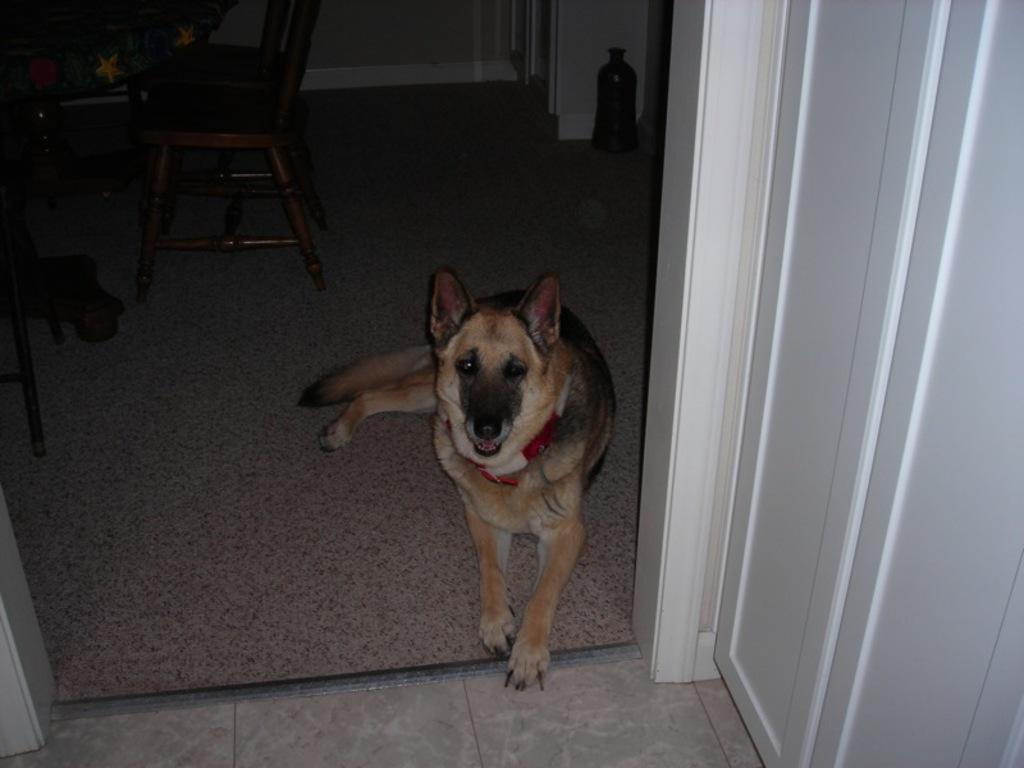What type of animal is in the picture? There is a dog in the picture. What type of furniture can be seen in the picture? There are chairs and a table in the picture. What object is visible that might contain a liquid? There is a bottle visible in the picture. What architectural feature is present in the picture? There is a door in the picture. Can you tell me where the queen is sitting in the picture? There is no queen present in the picture; it features a dog, chairs, a table, a bottle, and a door. What type of mountain is visible in the picture? There is no mountain present in the picture. 